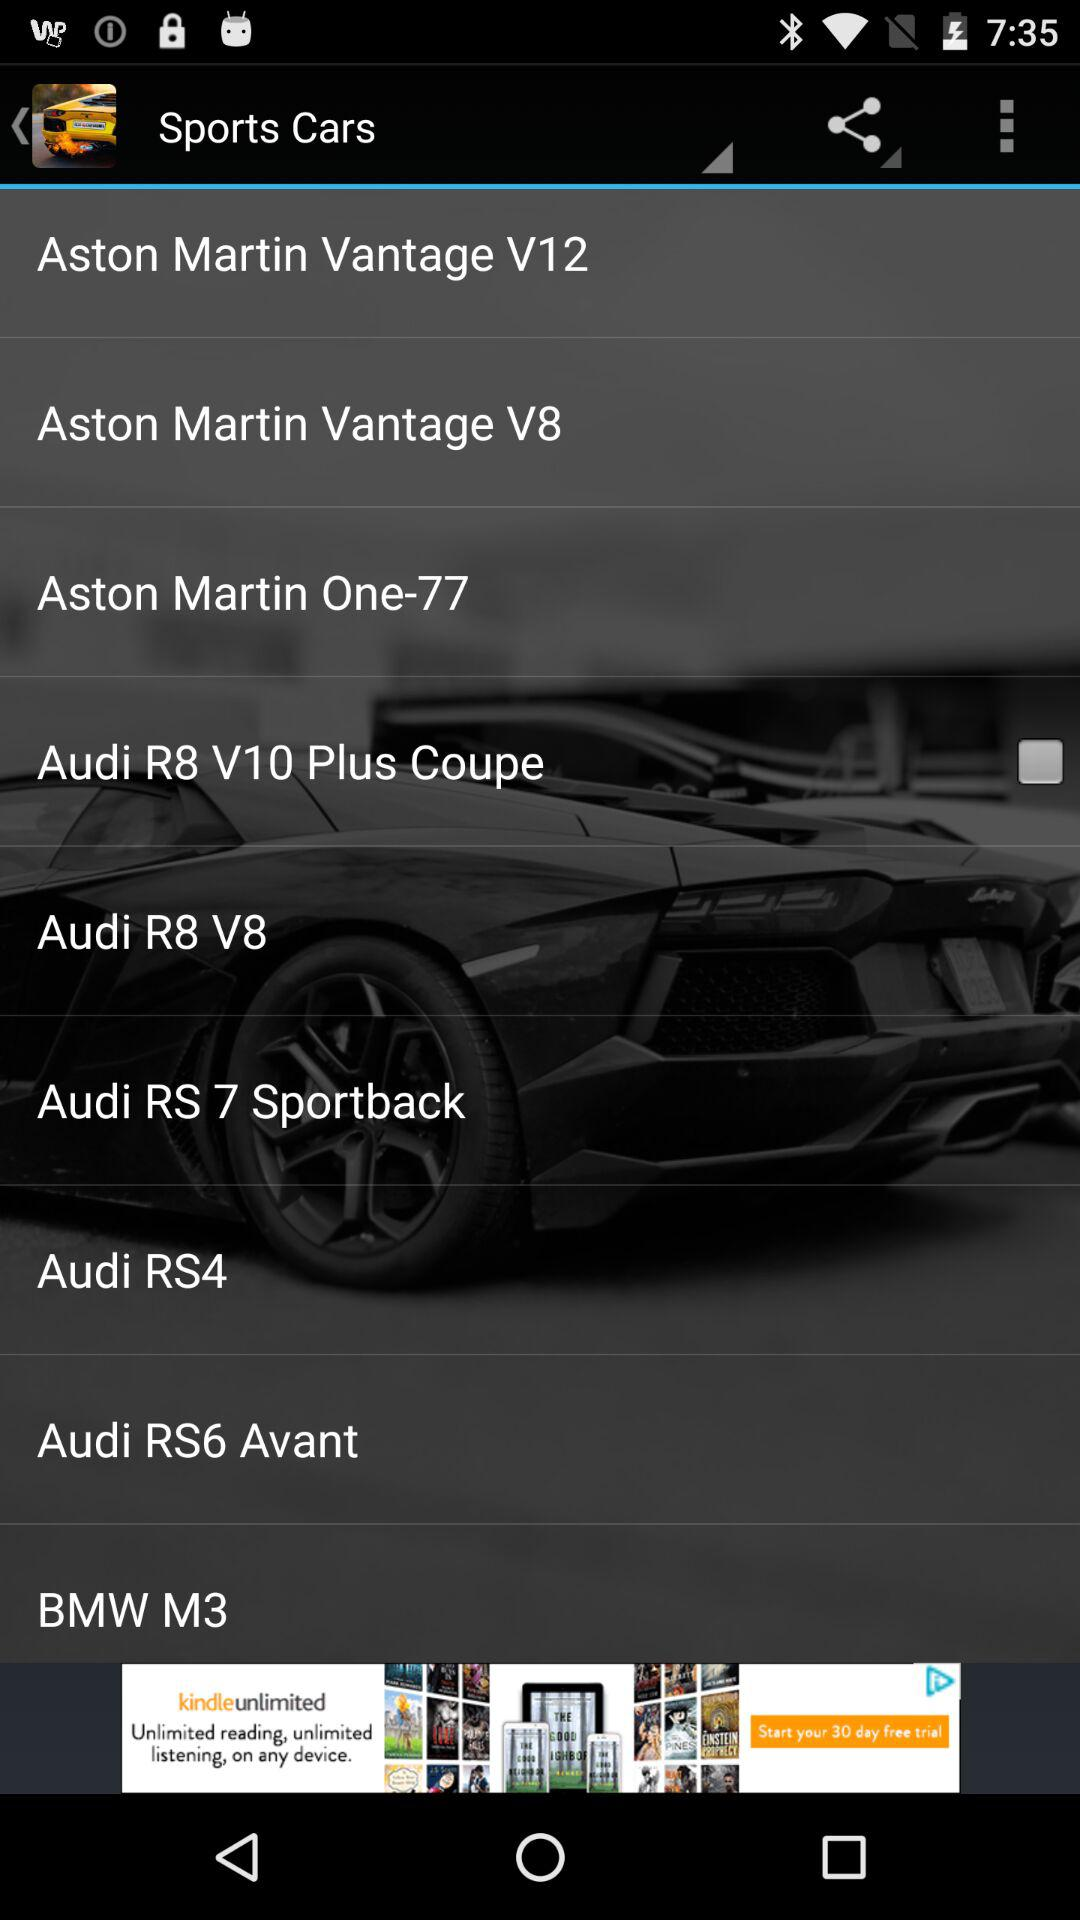What is the model of the BMW? The model of the BMW is "M3". 